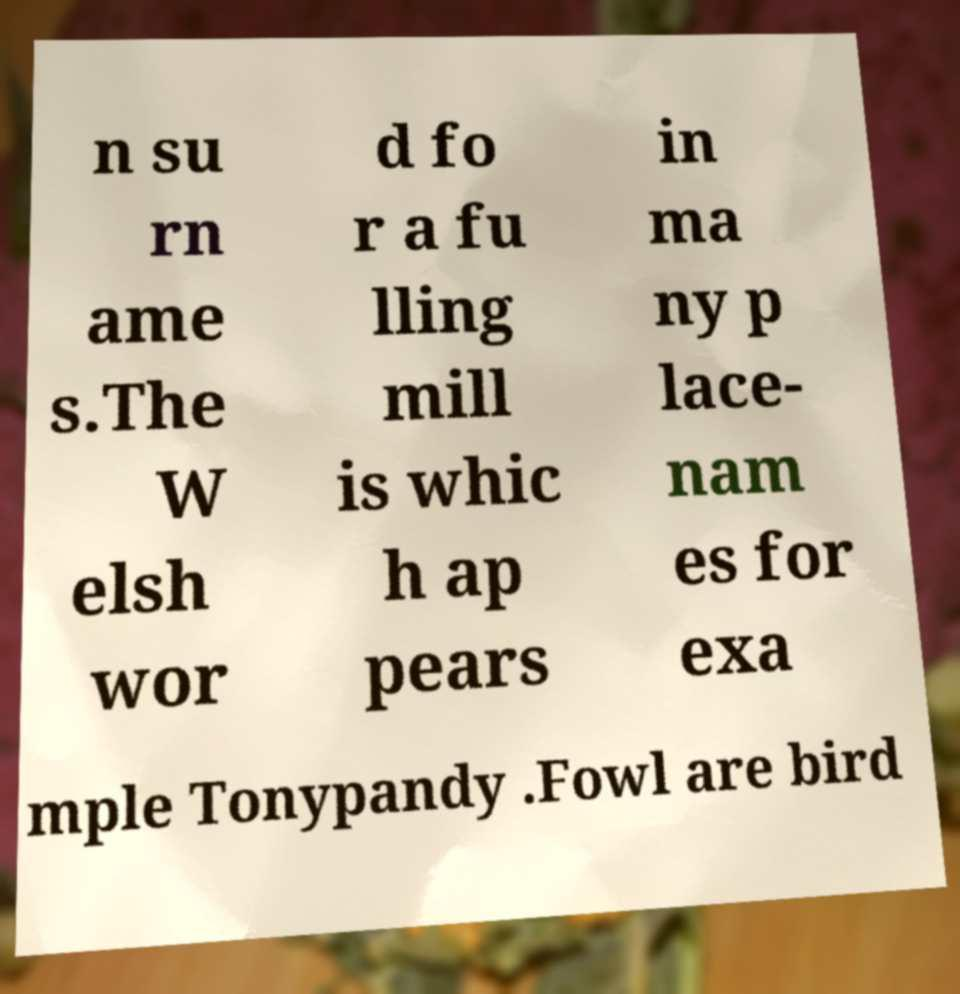Please read and relay the text visible in this image. What does it say? n su rn ame s.The W elsh wor d fo r a fu lling mill is whic h ap pears in ma ny p lace- nam es for exa mple Tonypandy .Fowl are bird 